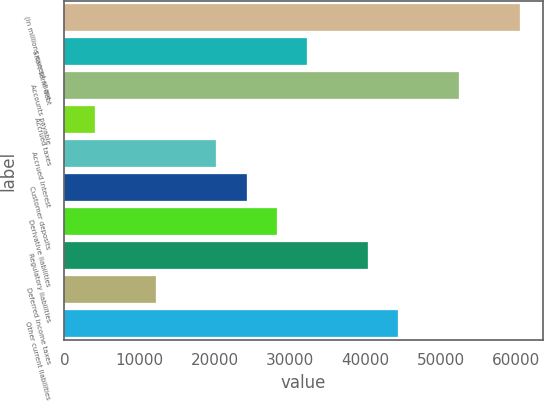<chart> <loc_0><loc_0><loc_500><loc_500><bar_chart><fcel>(in millions except share<fcel>Short-term debt<fcel>Accounts payable<fcel>Accrued taxes<fcel>Accrued interest<fcel>Customer deposits<fcel>Derivative liabilities<fcel>Regulatory liabilities<fcel>Deferred income taxes<fcel>Other current liabilities<nl><fcel>60460.5<fcel>32256.8<fcel>52402.3<fcel>4053.1<fcel>20169.5<fcel>24198.6<fcel>28227.7<fcel>40315<fcel>12111.3<fcel>44344.1<nl></chart> 